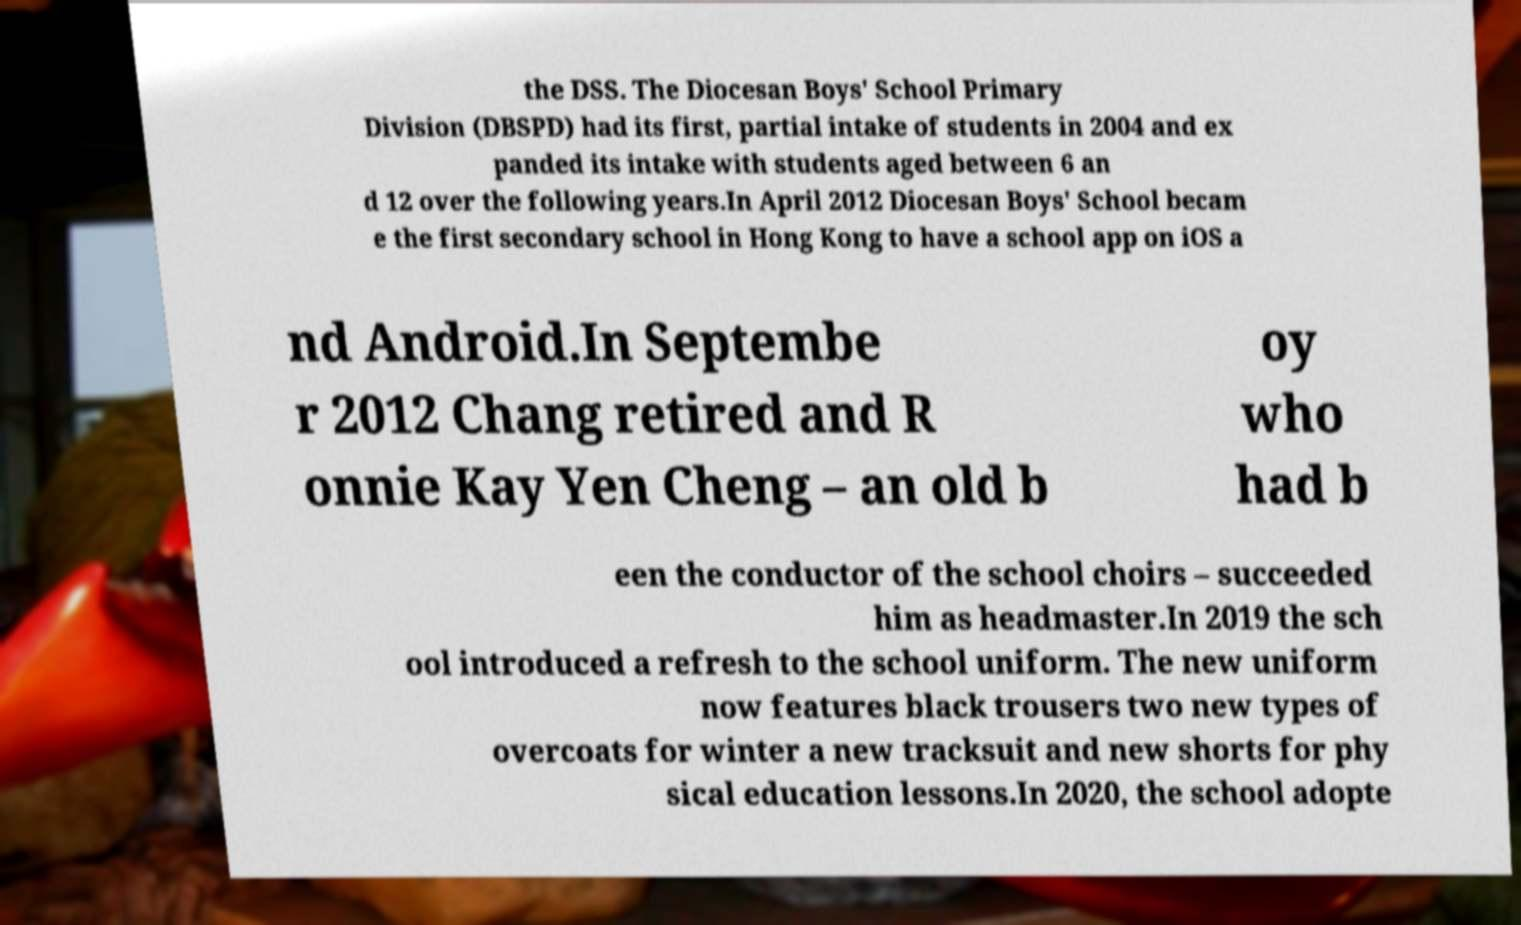There's text embedded in this image that I need extracted. Can you transcribe it verbatim? the DSS. The Diocesan Boys' School Primary Division (DBSPD) had its first, partial intake of students in 2004 and ex panded its intake with students aged between 6 an d 12 over the following years.In April 2012 Diocesan Boys' School becam e the first secondary school in Hong Kong to have a school app on iOS a nd Android.In Septembe r 2012 Chang retired and R onnie Kay Yen Cheng – an old b oy who had b een the conductor of the school choirs – succeeded him as headmaster.In 2019 the sch ool introduced a refresh to the school uniform. The new uniform now features black trousers two new types of overcoats for winter a new tracksuit and new shorts for phy sical education lessons.In 2020, the school adopte 